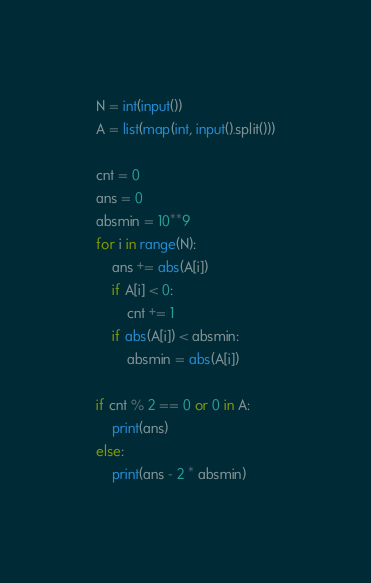<code> <loc_0><loc_0><loc_500><loc_500><_Python_>N = int(input())
A = list(map(int, input().split()))

cnt = 0
ans = 0
absmin = 10**9
for i in range(N):
    ans += abs(A[i])
    if A[i] < 0:
        cnt += 1
    if abs(A[i]) < absmin:
        absmin = abs(A[i])

if cnt % 2 == 0 or 0 in A:
    print(ans)
else:
    print(ans - 2 * absmin)
</code> 